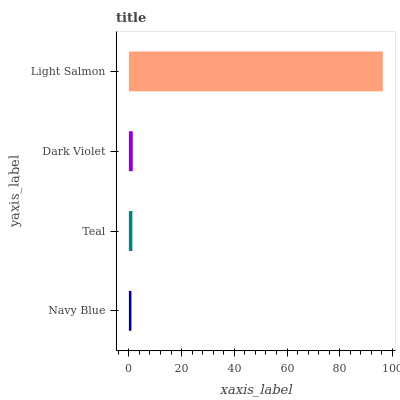Is Navy Blue the minimum?
Answer yes or no. Yes. Is Light Salmon the maximum?
Answer yes or no. Yes. Is Teal the minimum?
Answer yes or no. No. Is Teal the maximum?
Answer yes or no. No. Is Teal greater than Navy Blue?
Answer yes or no. Yes. Is Navy Blue less than Teal?
Answer yes or no. Yes. Is Navy Blue greater than Teal?
Answer yes or no. No. Is Teal less than Navy Blue?
Answer yes or no. No. Is Dark Violet the high median?
Answer yes or no. Yes. Is Teal the low median?
Answer yes or no. Yes. Is Navy Blue the high median?
Answer yes or no. No. Is Light Salmon the low median?
Answer yes or no. No. 